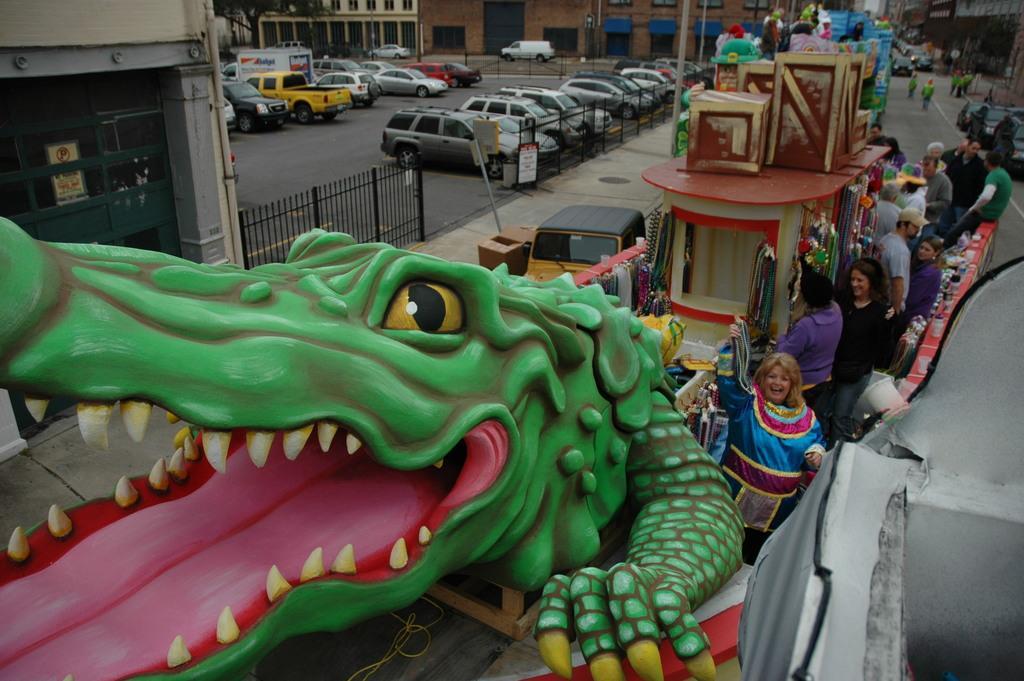Please provide a concise description of this image. In this image, in the right corner, we can see some objects. On the right side, we can see a group of people standing. On the right side, we can see a building, a group of people, vehicles. In the middle of the image, we can see a toy crocodile and few boxes. On the left side, we can see a building, metal grill, few vehicles. In the background, we can see some trees, building, window. At the bottom, we can see a road and a footpath. 